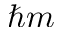<formula> <loc_0><loc_0><loc_500><loc_500>\hbar { m }</formula> 